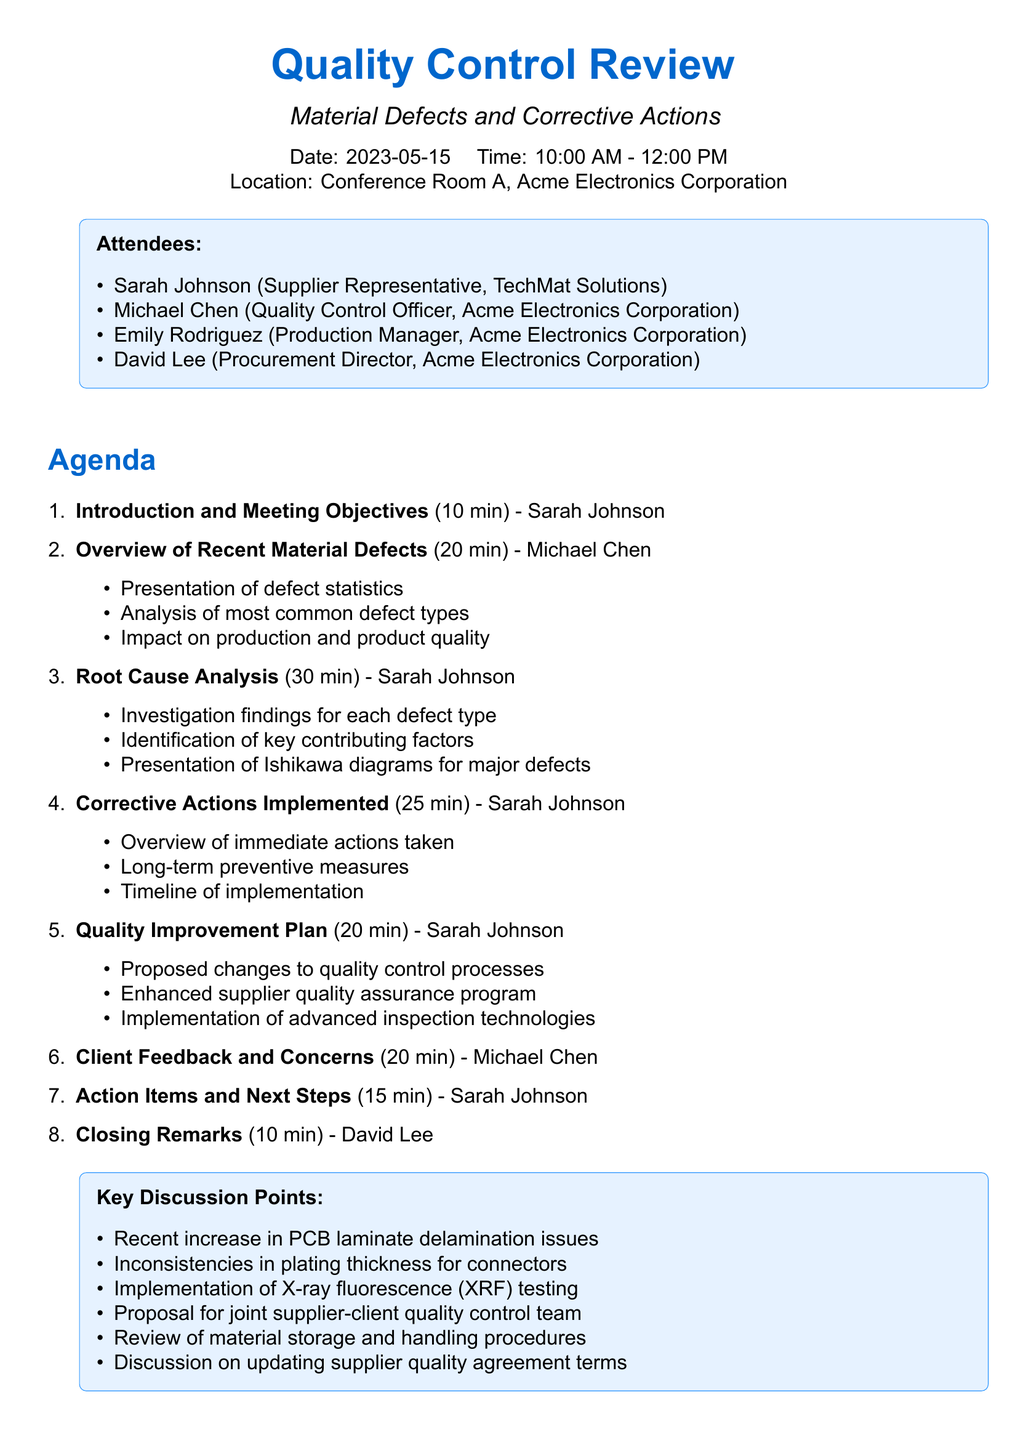What is the meeting title? The meeting title is the primary subject of the agenda and is stated clearly at the top.
Answer: Quality Control Review: Material Defects and Corrective Actions Who is the presenter for the Root Cause Analysis section? The agenda specifies the name of the individual responsible for presenting each section.
Answer: Sarah Johnson What is the duration allocated for Client Feedback and Concerns? The agenda includes the time duration for each agenda item, which helps in understanding the meeting schedule.
Answer: 20 minutes What key issue will be discussed regarding PCB? The document lists specific discussion points, highlighting critical issues to address.
Answer: Laminate delamination issues What materials are prepared by the TechMat Solutions Quality Assurance Team? The document provides a list of materials that are reviewed alongside the agenda, indicating authorship and content.
Answer: Defect Analysis Report 